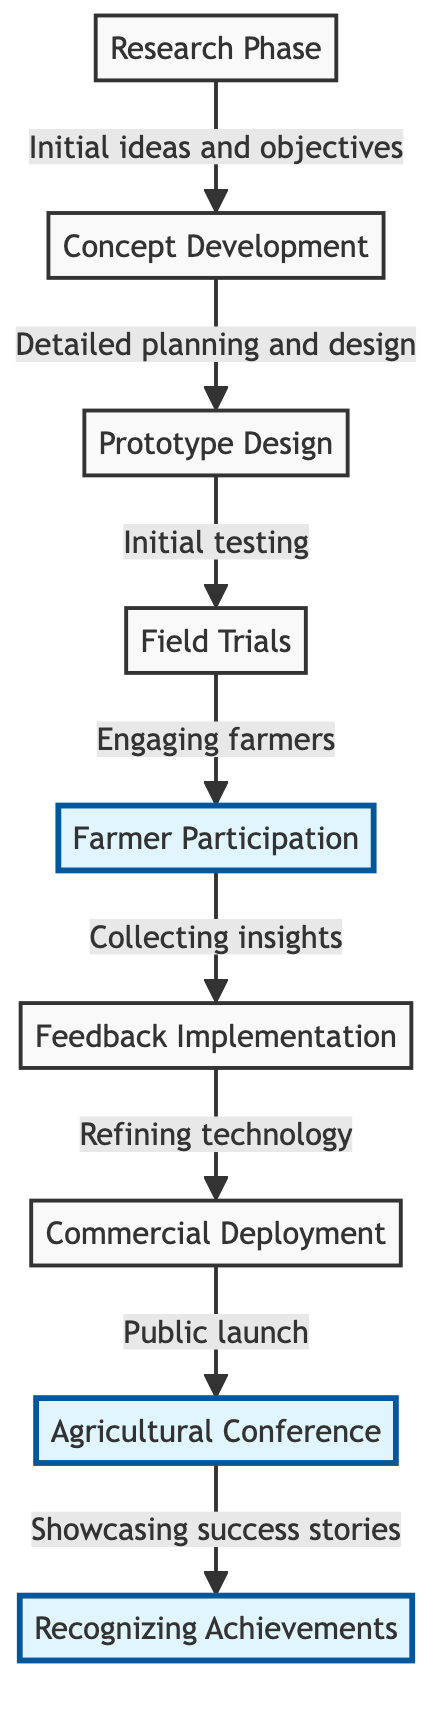What is the first phase in the agricultural innovations journey? The first phase in the journey is represented as a node labeled "Research Phase." This is established at the beginning of the flowchart.
Answer: Research Phase How many key milestones are there in the diagram? By counting the distinct nodes in the flowchart, there are a total of 7 key milestones outlined in the journey depicted in the diagram.
Answer: 7 What follows after the "Field Trials" phase? According to the flowchart, the phase that directly follows "Field Trials" is "Farmer Participation," indicating the next step in the sequence.
Answer: Farmer Participation What is the purpose of the "Agricultural Conference" node? The node "Agricultural Conference" serves the purpose of being the point where the outcomes are publicized, specifically showcasing success stories, as indicated by the label connected to this node.
Answer: Showcasing success stories Which phase directly involves farmers? The node "Farmer Participation" directly involves farmers, detailing the phase where farmers engage in the process to assist in the development and testing of innovations.
Answer: Farmer Participation What happens after "Feedback Implementation"? After "Feedback Implementation," the next step is "Commercial Deployment," indicating that the feedback received is utilized to refine the technology before it goes to market.
Answer: Commercial Deployment Which phases highlight farmer contributions? The phases specifically highlighting farmer contributions are "Farmer Participation," "Feedback Implementation," and "Agricultural Conference," as they focus on farmer involvement and recognition.
Answer: Farmer Participation, Feedback Implementation, Agricultural Conference How is farmer input utilized in the innovation process? Farmer input is utilized during the "Feedback Implementation" phase, where insights collected from farmers are incorporated to refine the technology before its commercial launch.
Answer: Refining technology What is the last milestone represented in the diagram? The last milestone represented in the diagram is the "Recognizing Achievements" node, which signifies the conclusion of the innovation process with acknowledgment of farmers' contributions.
Answer: Recognizing Achievements 